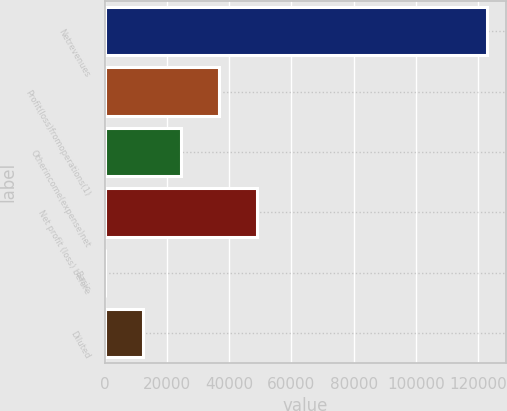Convert chart. <chart><loc_0><loc_0><loc_500><loc_500><bar_chart><fcel>Netrevenues<fcel>Profit(loss)fromoperations(1)<fcel>Otherincome(expense)net<fcel>Net profit (loss) before<fcel>Basic<fcel>Diluted<nl><fcel>122725<fcel>36817.7<fcel>24545.3<fcel>49090.2<fcel>0.35<fcel>12272.8<nl></chart> 